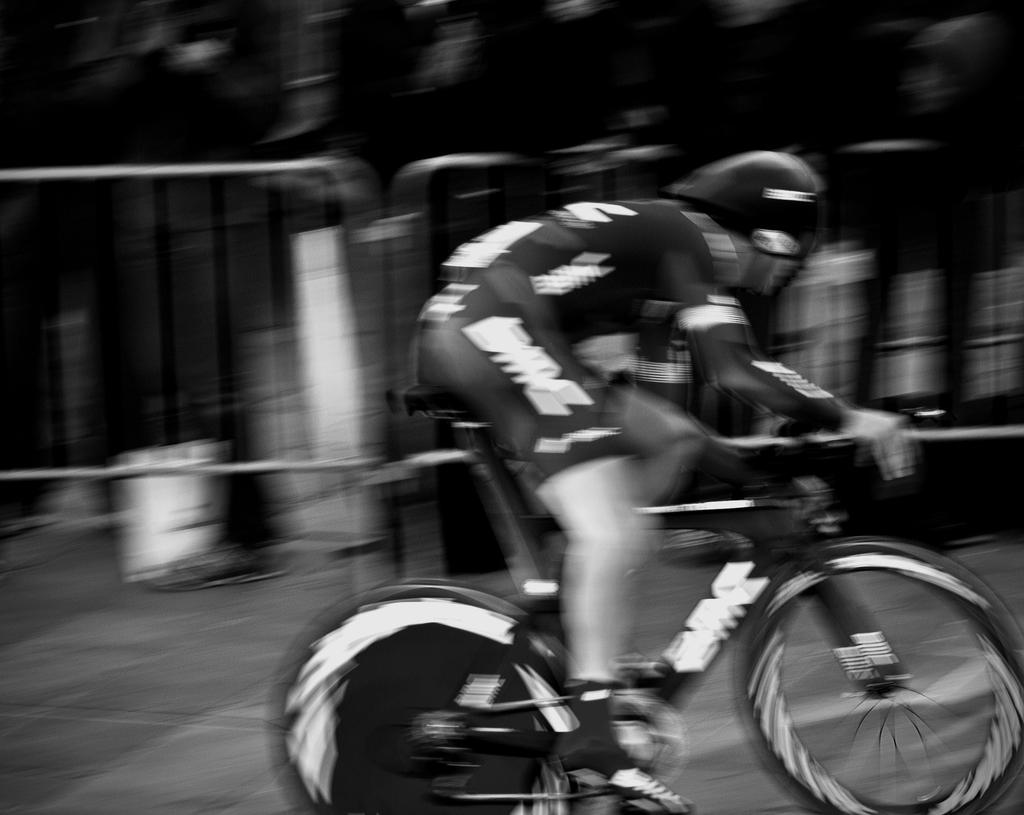What is the main subject of the image? There is a person riding a bicycle in the image. What can be seen behind the person riding the bicycle? There are railings behind the person riding the bicycle. Are there any other people visible in the image? Yes, there is a group of people standing in the image. Where is the store located in the image? There is no store present in the image. Is there a fire visible in the image? No, there is no fire visible in the image. 